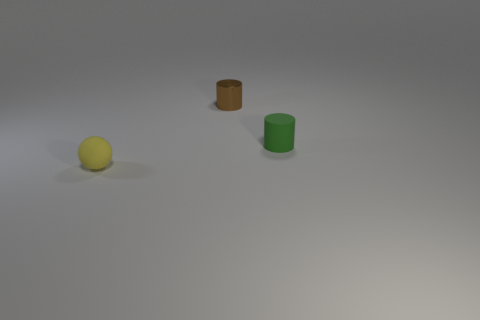What number of cubes are either big purple rubber objects or small yellow things?
Provide a succinct answer. 0. Is there a large brown metallic thing of the same shape as the green rubber thing?
Your response must be concise. No. What is the shape of the tiny green rubber thing?
Make the answer very short. Cylinder. What number of things are either tiny green matte cylinders or small shiny cubes?
Provide a succinct answer. 1. Is the size of the thing that is right of the brown thing the same as the thing that is left of the small brown metallic thing?
Your answer should be compact. Yes. What number of other things are made of the same material as the green cylinder?
Ensure brevity in your answer.  1. Are there more small yellow balls behind the green thing than green cylinders on the left side of the small brown metallic cylinder?
Ensure brevity in your answer.  No. There is a tiny object in front of the green rubber thing; what is its material?
Provide a short and direct response. Rubber. Is the shape of the green matte object the same as the tiny yellow rubber thing?
Your answer should be compact. No. Are there any other things that have the same color as the tiny rubber ball?
Your response must be concise. No. 